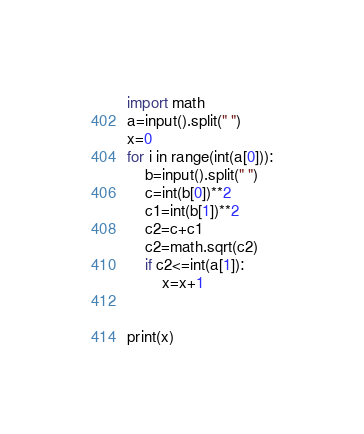<code> <loc_0><loc_0><loc_500><loc_500><_Python_>import math
a=input().split(" ")
x=0
for i in range(int(a[0])):
    b=input().split(" ")
    c=int(b[0])**2
    c1=int(b[1])**2
    c2=c+c1
    c2=math.sqrt(c2)
    if c2<=int(a[1]):
        x=x+1
    

print(x)


</code> 